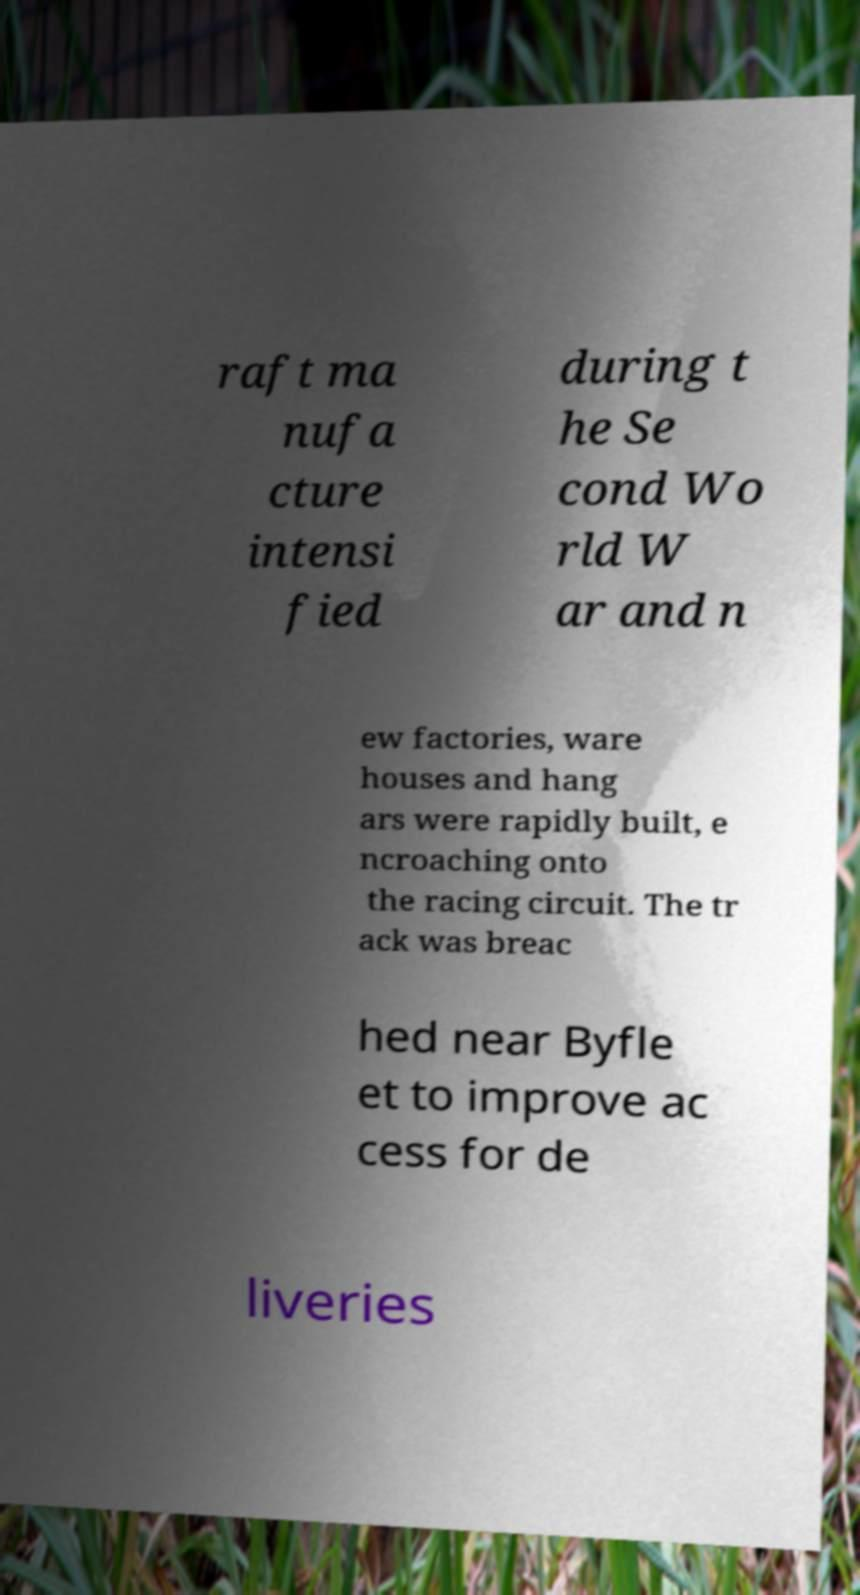What messages or text are displayed in this image? I need them in a readable, typed format. raft ma nufa cture intensi fied during t he Se cond Wo rld W ar and n ew factories, ware houses and hang ars were rapidly built, e ncroaching onto the racing circuit. The tr ack was breac hed near Byfle et to improve ac cess for de liveries 